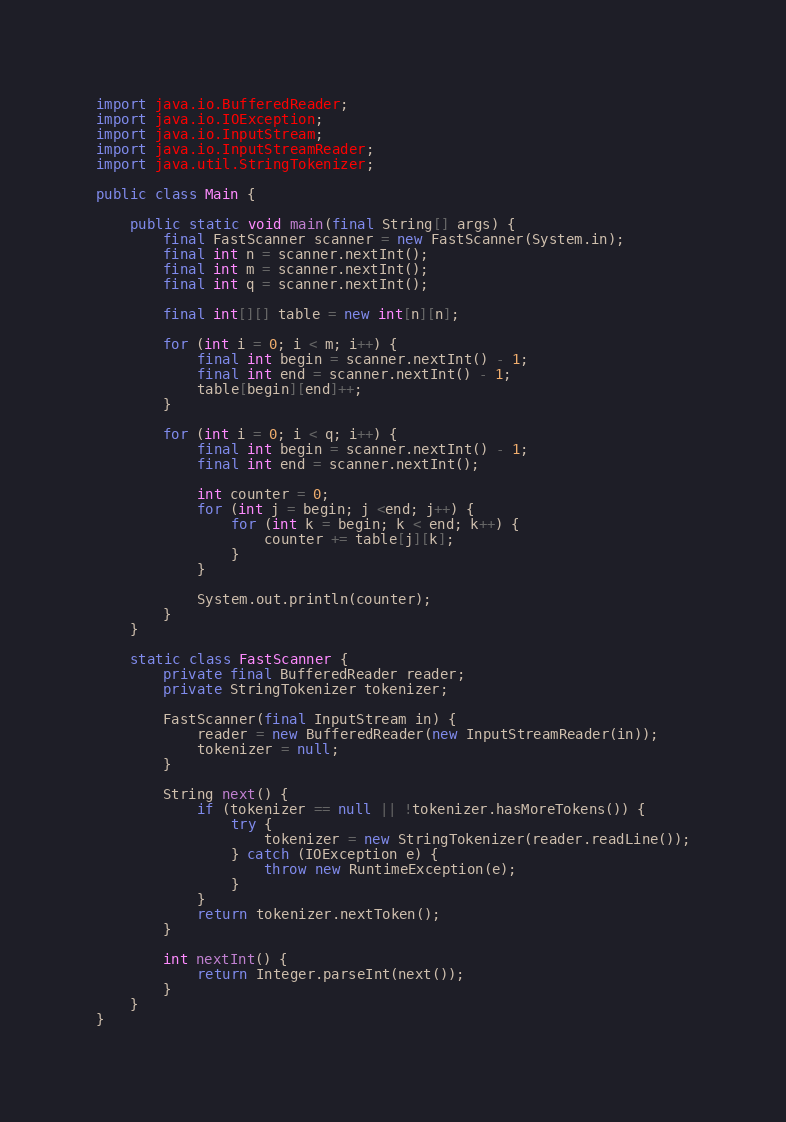<code> <loc_0><loc_0><loc_500><loc_500><_Java_>
import java.io.BufferedReader;
import java.io.IOException;
import java.io.InputStream;
import java.io.InputStreamReader;
import java.util.StringTokenizer;

public class Main {

    public static void main(final String[] args) {
        final FastScanner scanner = new FastScanner(System.in);
        final int n = scanner.nextInt();
        final int m = scanner.nextInt();
        final int q = scanner.nextInt();

        final int[][] table = new int[n][n];

        for (int i = 0; i < m; i++) {
            final int begin = scanner.nextInt() - 1;
            final int end = scanner.nextInt() - 1;
            table[begin][end]++;
        }

        for (int i = 0; i < q; i++) {
            final int begin = scanner.nextInt() - 1;
            final int end = scanner.nextInt();

            int counter = 0;
            for (int j = begin; j <end; j++) {
                for (int k = begin; k < end; k++) {
                    counter += table[j][k];
                }
            }

			System.out.println(counter);
        }
    }

    static class FastScanner {
        private final BufferedReader reader;
        private StringTokenizer tokenizer;

        FastScanner(final InputStream in) {
            reader = new BufferedReader(new InputStreamReader(in));
            tokenizer = null;
        }

        String next() {
            if (tokenizer == null || !tokenizer.hasMoreTokens()) {
                try {
                    tokenizer = new StringTokenizer(reader.readLine());
                } catch (IOException e) {
                    throw new RuntimeException(e);
                }
            }
            return tokenizer.nextToken();
        }

        int nextInt() {
            return Integer.parseInt(next());
        }
    }
}
</code> 